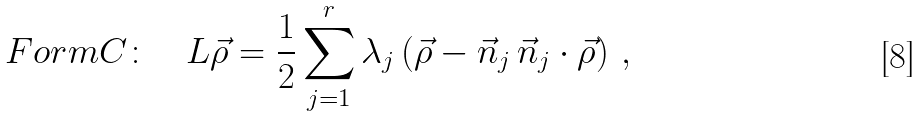Convert formula to latex. <formula><loc_0><loc_0><loc_500><loc_500>F o r m C \colon \quad L \vec { \rho } = \frac { 1 } { 2 } \sum _ { j = 1 } ^ { r } \lambda _ { j } \left ( \vec { \rho } - \vec { n } _ { j } \, \vec { n } _ { j } \cdot \vec { \rho } \right ) \, ,</formula> 